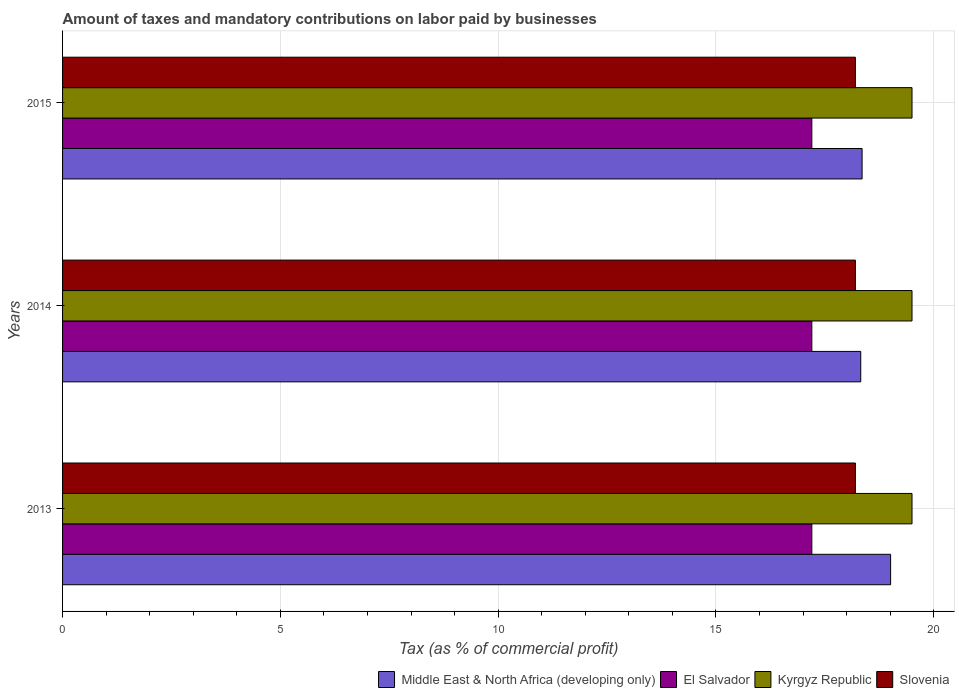How many groups of bars are there?
Keep it short and to the point. 3. Are the number of bars on each tick of the Y-axis equal?
Your response must be concise. Yes. In how many cases, is the number of bars for a given year not equal to the number of legend labels?
Offer a terse response. 0. What is the percentage of taxes paid by businesses in El Salvador in 2014?
Offer a very short reply. 17.2. Across all years, what is the maximum percentage of taxes paid by businesses in Middle East & North Africa (developing only)?
Make the answer very short. 19.01. In which year was the percentage of taxes paid by businesses in Middle East & North Africa (developing only) maximum?
Offer a very short reply. 2013. In which year was the percentage of taxes paid by businesses in El Salvador minimum?
Keep it short and to the point. 2013. What is the total percentage of taxes paid by businesses in Kyrgyz Republic in the graph?
Give a very brief answer. 58.5. What is the average percentage of taxes paid by businesses in Slovenia per year?
Your response must be concise. 18.2. In the year 2015, what is the difference between the percentage of taxes paid by businesses in El Salvador and percentage of taxes paid by businesses in Kyrgyz Republic?
Keep it short and to the point. -2.3. In how many years, is the percentage of taxes paid by businesses in Kyrgyz Republic greater than 11 %?
Provide a short and direct response. 3. What is the difference between the highest and the second highest percentage of taxes paid by businesses in Middle East & North Africa (developing only)?
Your answer should be very brief. 0.65. What is the difference between the highest and the lowest percentage of taxes paid by businesses in El Salvador?
Your answer should be very brief. 0. In how many years, is the percentage of taxes paid by businesses in Kyrgyz Republic greater than the average percentage of taxes paid by businesses in Kyrgyz Republic taken over all years?
Ensure brevity in your answer.  0. Is it the case that in every year, the sum of the percentage of taxes paid by businesses in Kyrgyz Republic and percentage of taxes paid by businesses in Slovenia is greater than the sum of percentage of taxes paid by businesses in El Salvador and percentage of taxes paid by businesses in Middle East & North Africa (developing only)?
Ensure brevity in your answer.  No. What does the 2nd bar from the top in 2014 represents?
Your answer should be compact. Kyrgyz Republic. What does the 3rd bar from the bottom in 2015 represents?
Your answer should be very brief. Kyrgyz Republic. Is it the case that in every year, the sum of the percentage of taxes paid by businesses in El Salvador and percentage of taxes paid by businesses in Kyrgyz Republic is greater than the percentage of taxes paid by businesses in Slovenia?
Provide a succinct answer. Yes. Are all the bars in the graph horizontal?
Provide a succinct answer. Yes. Are the values on the major ticks of X-axis written in scientific E-notation?
Ensure brevity in your answer.  No. Does the graph contain grids?
Your response must be concise. Yes. How many legend labels are there?
Your answer should be compact. 4. How are the legend labels stacked?
Make the answer very short. Horizontal. What is the title of the graph?
Make the answer very short. Amount of taxes and mandatory contributions on labor paid by businesses. What is the label or title of the X-axis?
Provide a short and direct response. Tax (as % of commercial profit). What is the label or title of the Y-axis?
Your answer should be very brief. Years. What is the Tax (as % of commercial profit) in Middle East & North Africa (developing only) in 2013?
Offer a very short reply. 19.01. What is the Tax (as % of commercial profit) in Slovenia in 2013?
Offer a very short reply. 18.2. What is the Tax (as % of commercial profit) of Middle East & North Africa (developing only) in 2014?
Your answer should be very brief. 18.32. What is the Tax (as % of commercial profit) of Slovenia in 2014?
Ensure brevity in your answer.  18.2. What is the Tax (as % of commercial profit) of Middle East & North Africa (developing only) in 2015?
Your answer should be very brief. 18.35. What is the Tax (as % of commercial profit) in Slovenia in 2015?
Give a very brief answer. 18.2. Across all years, what is the maximum Tax (as % of commercial profit) in Middle East & North Africa (developing only)?
Give a very brief answer. 19.01. Across all years, what is the maximum Tax (as % of commercial profit) of El Salvador?
Your response must be concise. 17.2. Across all years, what is the maximum Tax (as % of commercial profit) in Slovenia?
Your response must be concise. 18.2. Across all years, what is the minimum Tax (as % of commercial profit) in Middle East & North Africa (developing only)?
Ensure brevity in your answer.  18.32. Across all years, what is the minimum Tax (as % of commercial profit) of El Salvador?
Keep it short and to the point. 17.2. Across all years, what is the minimum Tax (as % of commercial profit) of Kyrgyz Republic?
Provide a succinct answer. 19.5. Across all years, what is the minimum Tax (as % of commercial profit) of Slovenia?
Your answer should be very brief. 18.2. What is the total Tax (as % of commercial profit) in Middle East & North Africa (developing only) in the graph?
Give a very brief answer. 55.69. What is the total Tax (as % of commercial profit) in El Salvador in the graph?
Your answer should be very brief. 51.6. What is the total Tax (as % of commercial profit) in Kyrgyz Republic in the graph?
Keep it short and to the point. 58.5. What is the total Tax (as % of commercial profit) of Slovenia in the graph?
Provide a succinct answer. 54.6. What is the difference between the Tax (as % of commercial profit) in Middle East & North Africa (developing only) in 2013 and that in 2014?
Provide a succinct answer. 0.69. What is the difference between the Tax (as % of commercial profit) in Kyrgyz Republic in 2013 and that in 2014?
Give a very brief answer. 0. What is the difference between the Tax (as % of commercial profit) in Middle East & North Africa (developing only) in 2013 and that in 2015?
Your answer should be compact. 0.65. What is the difference between the Tax (as % of commercial profit) in El Salvador in 2013 and that in 2015?
Offer a very short reply. 0. What is the difference between the Tax (as % of commercial profit) in Middle East & North Africa (developing only) in 2014 and that in 2015?
Keep it short and to the point. -0.03. What is the difference between the Tax (as % of commercial profit) in El Salvador in 2014 and that in 2015?
Your answer should be compact. 0. What is the difference between the Tax (as % of commercial profit) in Middle East & North Africa (developing only) in 2013 and the Tax (as % of commercial profit) in El Salvador in 2014?
Your answer should be compact. 1.81. What is the difference between the Tax (as % of commercial profit) of Middle East & North Africa (developing only) in 2013 and the Tax (as % of commercial profit) of Kyrgyz Republic in 2014?
Provide a short and direct response. -0.49. What is the difference between the Tax (as % of commercial profit) in Middle East & North Africa (developing only) in 2013 and the Tax (as % of commercial profit) in Slovenia in 2014?
Offer a very short reply. 0.81. What is the difference between the Tax (as % of commercial profit) in Kyrgyz Republic in 2013 and the Tax (as % of commercial profit) in Slovenia in 2014?
Give a very brief answer. 1.3. What is the difference between the Tax (as % of commercial profit) in Middle East & North Africa (developing only) in 2013 and the Tax (as % of commercial profit) in El Salvador in 2015?
Keep it short and to the point. 1.81. What is the difference between the Tax (as % of commercial profit) of Middle East & North Africa (developing only) in 2013 and the Tax (as % of commercial profit) of Kyrgyz Republic in 2015?
Make the answer very short. -0.49. What is the difference between the Tax (as % of commercial profit) in Middle East & North Africa (developing only) in 2013 and the Tax (as % of commercial profit) in Slovenia in 2015?
Provide a short and direct response. 0.81. What is the difference between the Tax (as % of commercial profit) in El Salvador in 2013 and the Tax (as % of commercial profit) in Slovenia in 2015?
Provide a short and direct response. -1. What is the difference between the Tax (as % of commercial profit) of Middle East & North Africa (developing only) in 2014 and the Tax (as % of commercial profit) of El Salvador in 2015?
Offer a very short reply. 1.12. What is the difference between the Tax (as % of commercial profit) in Middle East & North Africa (developing only) in 2014 and the Tax (as % of commercial profit) in Kyrgyz Republic in 2015?
Make the answer very short. -1.18. What is the difference between the Tax (as % of commercial profit) in Middle East & North Africa (developing only) in 2014 and the Tax (as % of commercial profit) in Slovenia in 2015?
Ensure brevity in your answer.  0.12. What is the difference between the Tax (as % of commercial profit) of El Salvador in 2014 and the Tax (as % of commercial profit) of Kyrgyz Republic in 2015?
Your answer should be very brief. -2.3. What is the difference between the Tax (as % of commercial profit) of El Salvador in 2014 and the Tax (as % of commercial profit) of Slovenia in 2015?
Make the answer very short. -1. What is the difference between the Tax (as % of commercial profit) in Kyrgyz Republic in 2014 and the Tax (as % of commercial profit) in Slovenia in 2015?
Offer a terse response. 1.3. What is the average Tax (as % of commercial profit) in Middle East & North Africa (developing only) per year?
Give a very brief answer. 18.56. In the year 2013, what is the difference between the Tax (as % of commercial profit) in Middle East & North Africa (developing only) and Tax (as % of commercial profit) in El Salvador?
Your answer should be compact. 1.81. In the year 2013, what is the difference between the Tax (as % of commercial profit) in Middle East & North Africa (developing only) and Tax (as % of commercial profit) in Kyrgyz Republic?
Your response must be concise. -0.49. In the year 2013, what is the difference between the Tax (as % of commercial profit) in Middle East & North Africa (developing only) and Tax (as % of commercial profit) in Slovenia?
Your answer should be compact. 0.81. In the year 2013, what is the difference between the Tax (as % of commercial profit) of El Salvador and Tax (as % of commercial profit) of Kyrgyz Republic?
Make the answer very short. -2.3. In the year 2014, what is the difference between the Tax (as % of commercial profit) of Middle East & North Africa (developing only) and Tax (as % of commercial profit) of El Salvador?
Provide a short and direct response. 1.12. In the year 2014, what is the difference between the Tax (as % of commercial profit) of Middle East & North Africa (developing only) and Tax (as % of commercial profit) of Kyrgyz Republic?
Your answer should be very brief. -1.18. In the year 2014, what is the difference between the Tax (as % of commercial profit) in Middle East & North Africa (developing only) and Tax (as % of commercial profit) in Slovenia?
Provide a short and direct response. 0.12. In the year 2014, what is the difference between the Tax (as % of commercial profit) in El Salvador and Tax (as % of commercial profit) in Slovenia?
Provide a short and direct response. -1. In the year 2014, what is the difference between the Tax (as % of commercial profit) of Kyrgyz Republic and Tax (as % of commercial profit) of Slovenia?
Your response must be concise. 1.3. In the year 2015, what is the difference between the Tax (as % of commercial profit) in Middle East & North Africa (developing only) and Tax (as % of commercial profit) in El Salvador?
Your response must be concise. 1.15. In the year 2015, what is the difference between the Tax (as % of commercial profit) of Middle East & North Africa (developing only) and Tax (as % of commercial profit) of Kyrgyz Republic?
Make the answer very short. -1.15. In the year 2015, what is the difference between the Tax (as % of commercial profit) of Middle East & North Africa (developing only) and Tax (as % of commercial profit) of Slovenia?
Provide a short and direct response. 0.15. In the year 2015, what is the difference between the Tax (as % of commercial profit) in El Salvador and Tax (as % of commercial profit) in Slovenia?
Your answer should be compact. -1. What is the ratio of the Tax (as % of commercial profit) of Middle East & North Africa (developing only) in 2013 to that in 2014?
Your answer should be compact. 1.04. What is the ratio of the Tax (as % of commercial profit) in El Salvador in 2013 to that in 2014?
Offer a terse response. 1. What is the ratio of the Tax (as % of commercial profit) of Slovenia in 2013 to that in 2014?
Make the answer very short. 1. What is the ratio of the Tax (as % of commercial profit) of Middle East & North Africa (developing only) in 2013 to that in 2015?
Provide a succinct answer. 1.04. What is the ratio of the Tax (as % of commercial profit) of El Salvador in 2013 to that in 2015?
Offer a terse response. 1. What is the ratio of the Tax (as % of commercial profit) in Middle East & North Africa (developing only) in 2014 to that in 2015?
Provide a succinct answer. 1. What is the difference between the highest and the second highest Tax (as % of commercial profit) of Middle East & North Africa (developing only)?
Give a very brief answer. 0.65. What is the difference between the highest and the second highest Tax (as % of commercial profit) in Kyrgyz Republic?
Give a very brief answer. 0. What is the difference between the highest and the second highest Tax (as % of commercial profit) of Slovenia?
Give a very brief answer. 0. What is the difference between the highest and the lowest Tax (as % of commercial profit) in Middle East & North Africa (developing only)?
Provide a succinct answer. 0.69. What is the difference between the highest and the lowest Tax (as % of commercial profit) of Slovenia?
Your response must be concise. 0. 